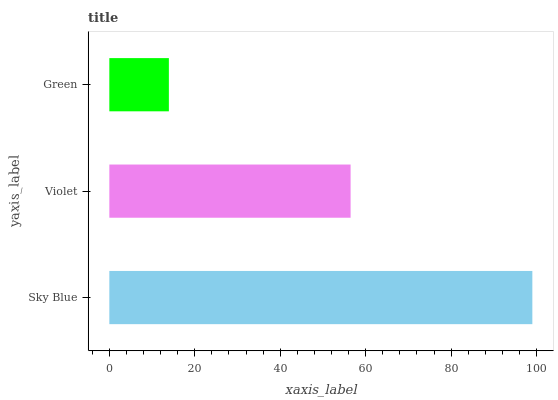Is Green the minimum?
Answer yes or no. Yes. Is Sky Blue the maximum?
Answer yes or no. Yes. Is Violet the minimum?
Answer yes or no. No. Is Violet the maximum?
Answer yes or no. No. Is Sky Blue greater than Violet?
Answer yes or no. Yes. Is Violet less than Sky Blue?
Answer yes or no. Yes. Is Violet greater than Sky Blue?
Answer yes or no. No. Is Sky Blue less than Violet?
Answer yes or no. No. Is Violet the high median?
Answer yes or no. Yes. Is Violet the low median?
Answer yes or no. Yes. Is Sky Blue the high median?
Answer yes or no. No. Is Green the low median?
Answer yes or no. No. 